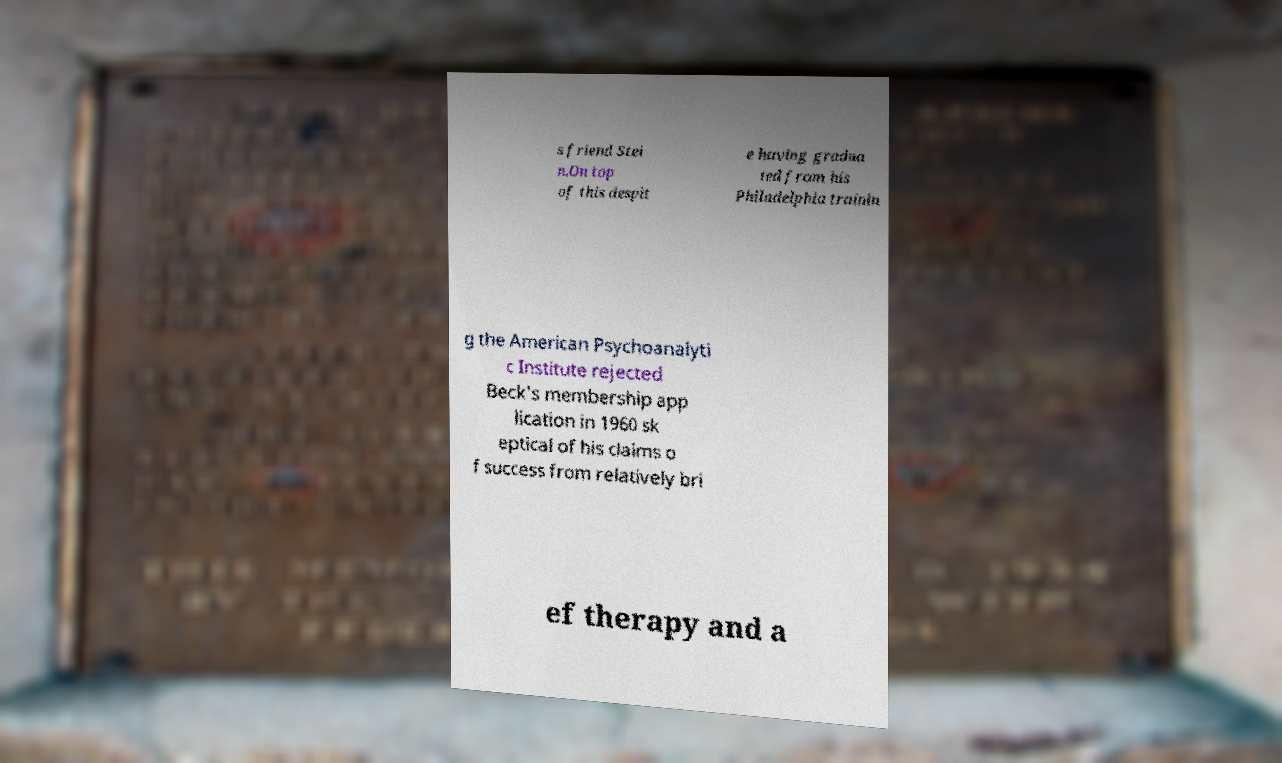Please read and relay the text visible in this image. What does it say? s friend Stei n.On top of this despit e having gradua ted from his Philadelphia trainin g the American Psychoanalyti c Institute rejected Beck's membership app lication in 1960 sk eptical of his claims o f success from relatively bri ef therapy and a 